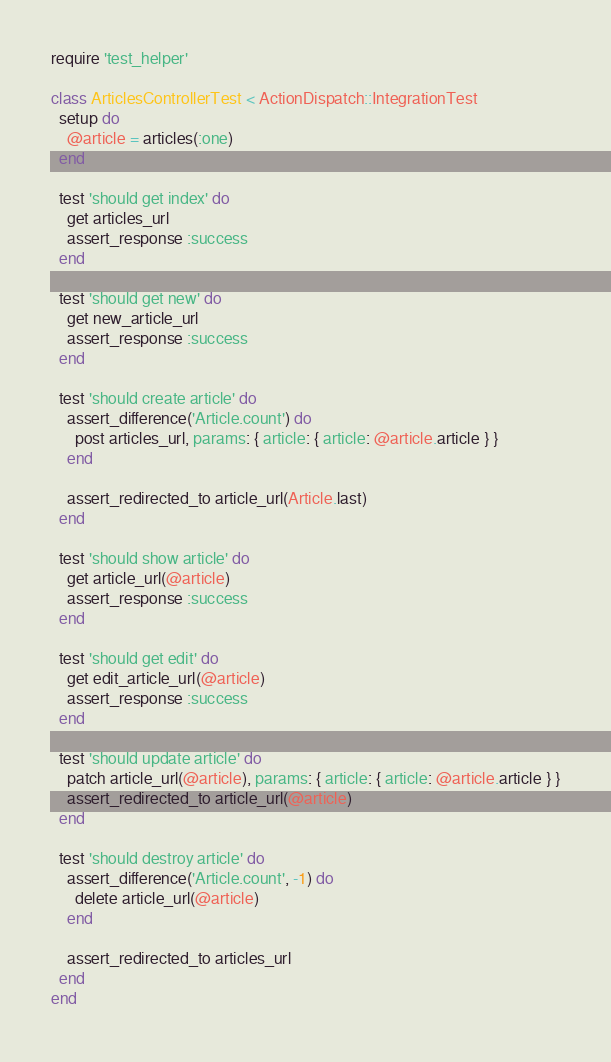Convert code to text. <code><loc_0><loc_0><loc_500><loc_500><_Ruby_>require 'test_helper'

class ArticlesControllerTest < ActionDispatch::IntegrationTest
  setup do
    @article = articles(:one)
  end

  test 'should get index' do
    get articles_url
    assert_response :success
  end

  test 'should get new' do
    get new_article_url
    assert_response :success
  end

  test 'should create article' do
    assert_difference('Article.count') do
      post articles_url, params: { article: { article: @article.article } }
    end

    assert_redirected_to article_url(Article.last)
  end

  test 'should show article' do
    get article_url(@article)
    assert_response :success
  end

  test 'should get edit' do
    get edit_article_url(@article)
    assert_response :success
  end

  test 'should update article' do
    patch article_url(@article), params: { article: { article: @article.article } }
    assert_redirected_to article_url(@article)
  end

  test 'should destroy article' do
    assert_difference('Article.count', -1) do
      delete article_url(@article)
    end

    assert_redirected_to articles_url
  end
end
</code> 